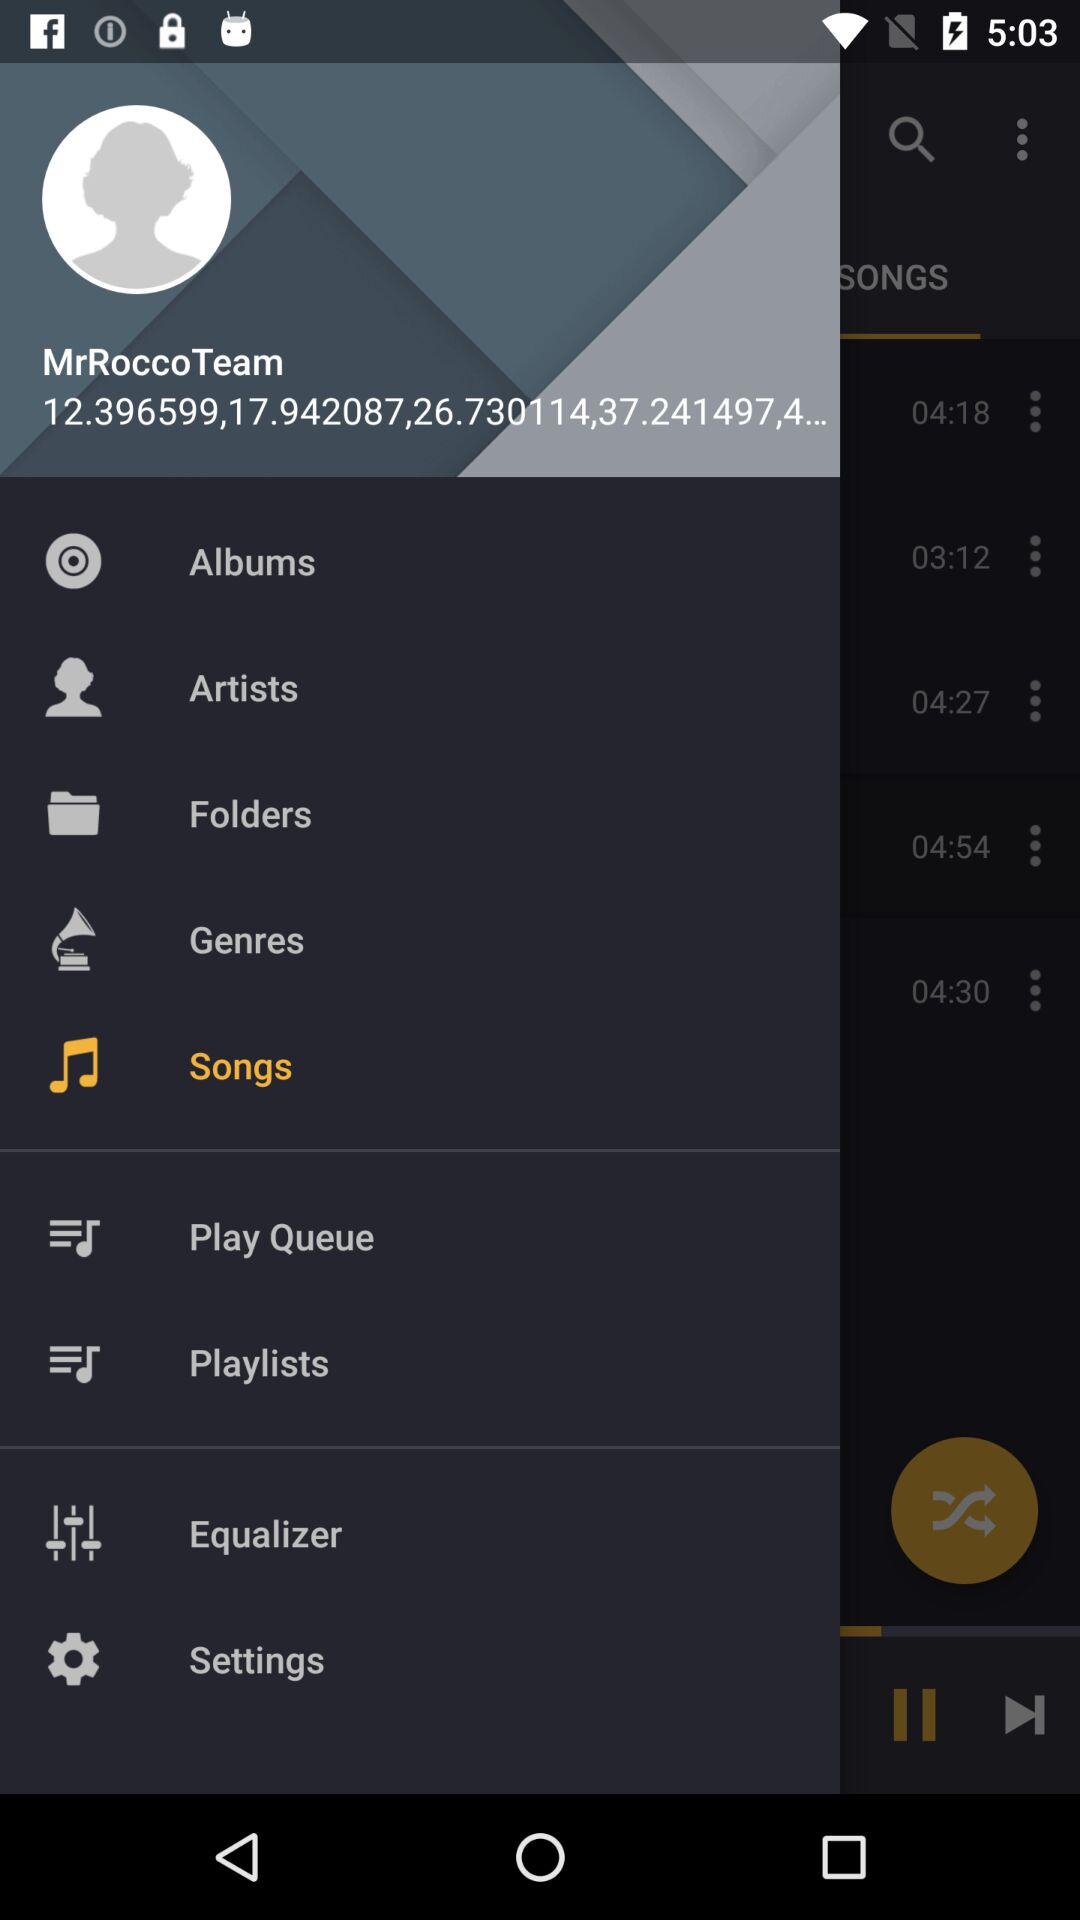Which option is selected? The selected option is "Songs". 